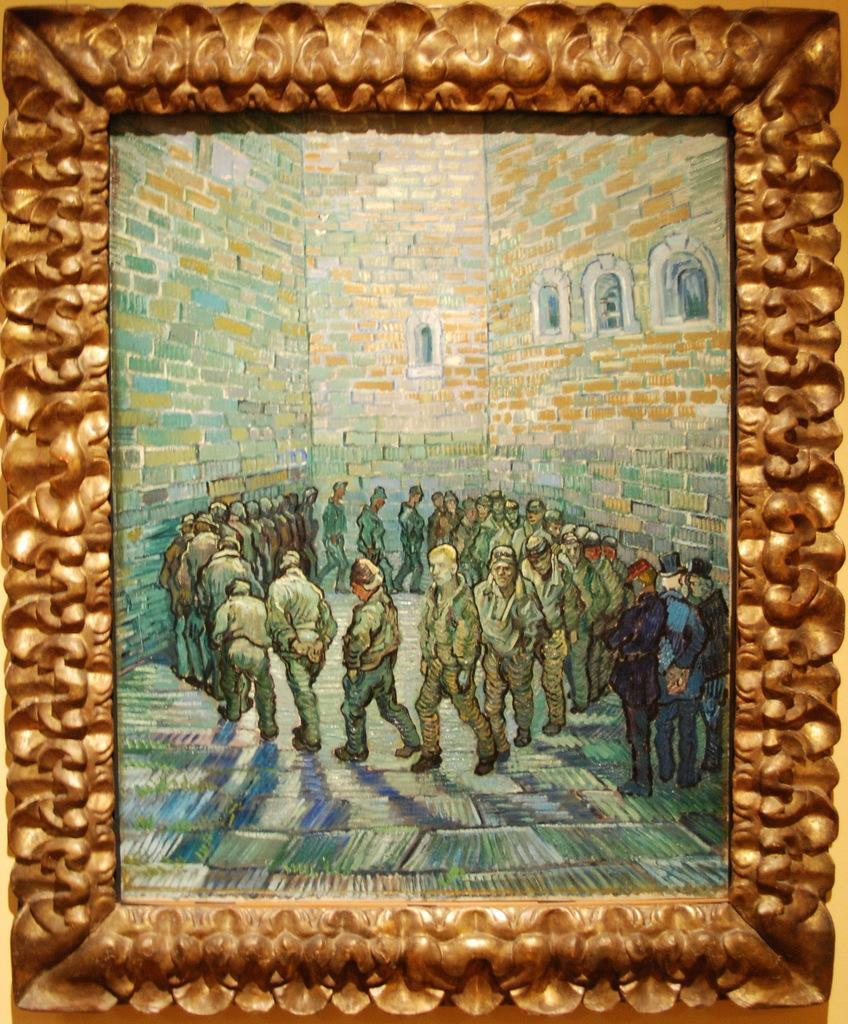Describe this image in one or two sentences. In this picture I can see the painting images which is placed on the wall. In that printing I can see the peoples were walking in the round. Beside them there are three persons were standing near to the brick wall. In the top right I can see the windows. 